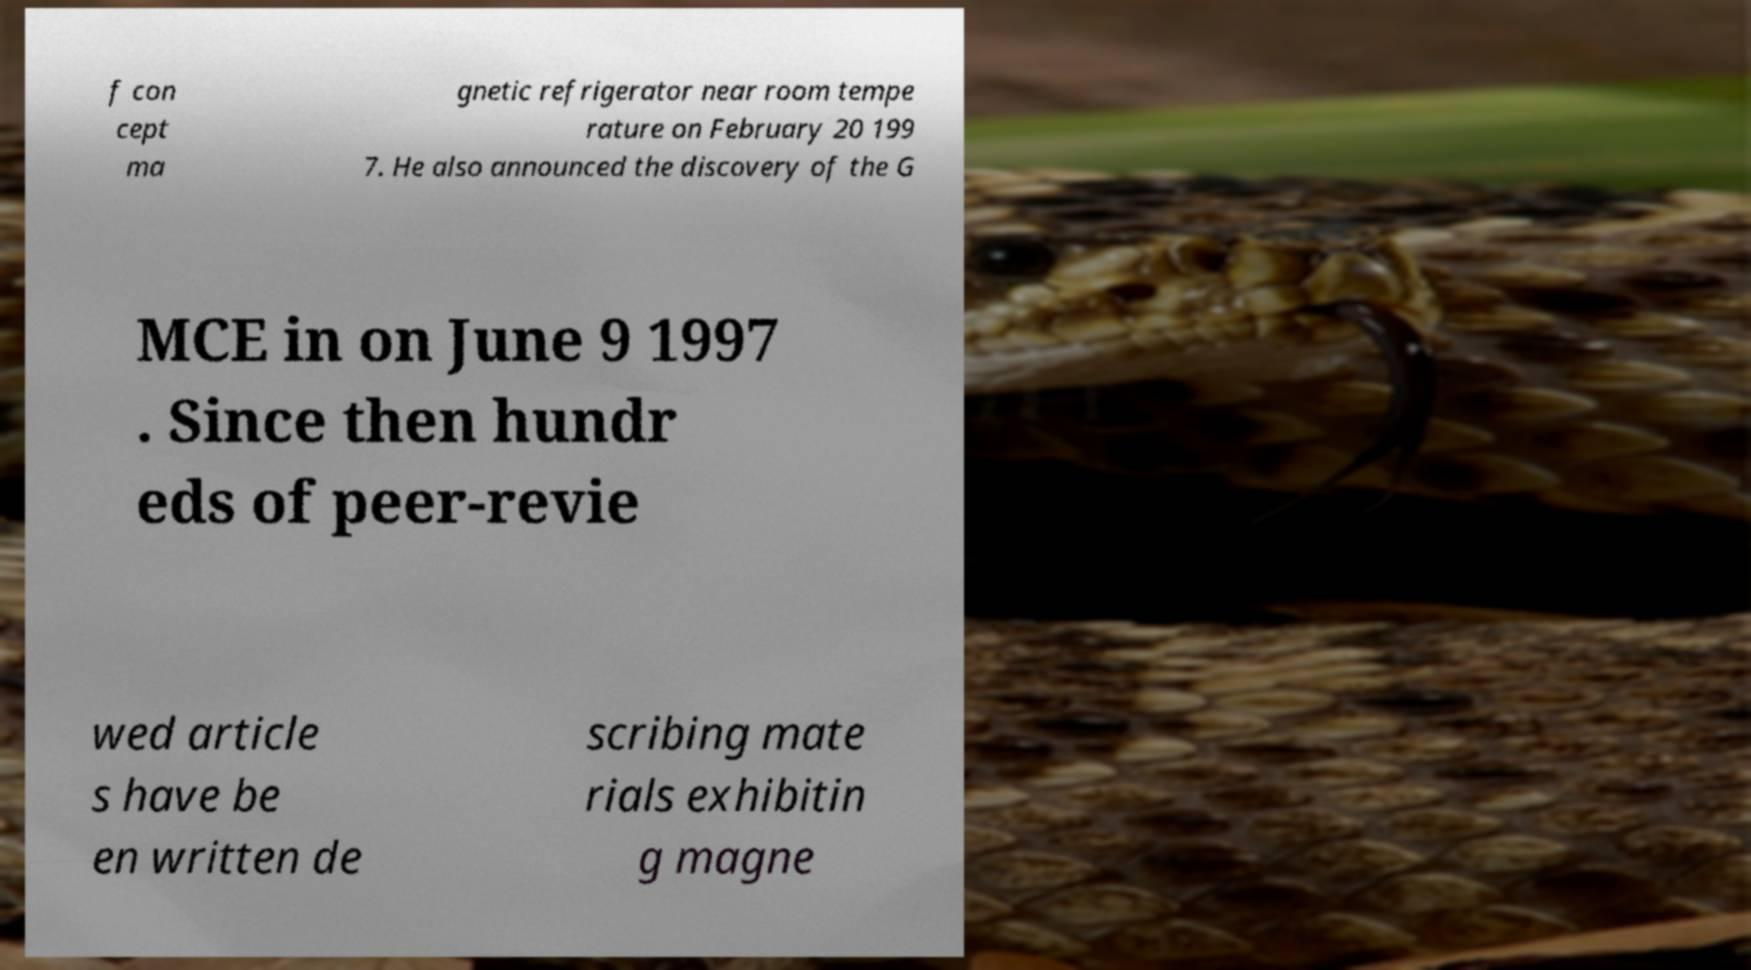There's text embedded in this image that I need extracted. Can you transcribe it verbatim? f con cept ma gnetic refrigerator near room tempe rature on February 20 199 7. He also announced the discovery of the G MCE in on June 9 1997 . Since then hundr eds of peer-revie wed article s have be en written de scribing mate rials exhibitin g magne 